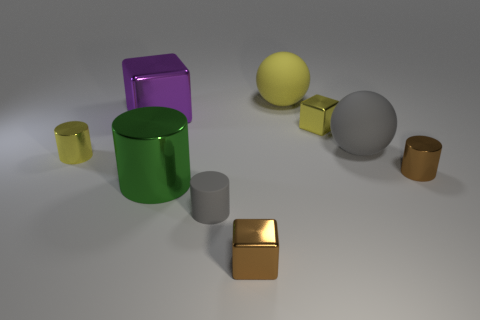Subtract all large cubes. How many cubes are left? 2 Subtract all yellow blocks. How many blocks are left? 2 Subtract all spheres. How many objects are left? 7 Subtract 2 blocks. How many blocks are left? 1 Subtract 0 green blocks. How many objects are left? 9 Subtract all cyan cubes. Subtract all green spheres. How many cubes are left? 3 Subtract all purple cylinders. How many blue balls are left? 0 Subtract all metal spheres. Subtract all tiny gray rubber cylinders. How many objects are left? 8 Add 1 yellow metallic blocks. How many yellow metallic blocks are left? 2 Add 2 small metallic objects. How many small metallic objects exist? 6 